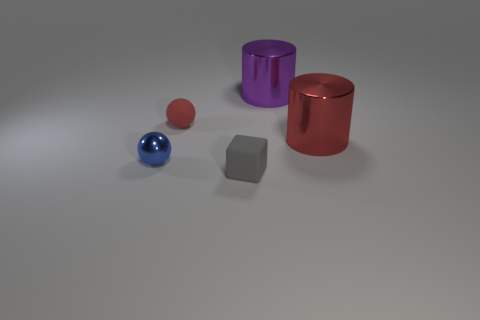Is the number of small gray cubes that are left of the small matte ball the same as the number of gray matte objects that are in front of the blue sphere?
Ensure brevity in your answer.  No. There is a object that is to the right of the purple shiny cylinder; what is its color?
Offer a terse response. Red. There is a small matte ball; does it have the same color as the metallic object on the left side of the big purple cylinder?
Make the answer very short. No. Are there fewer red rubber spheres than big yellow rubber cubes?
Ensure brevity in your answer.  No. Do the large shiny thing in front of the small red matte ball and the matte ball have the same color?
Your response must be concise. Yes. What number of gray rubber things have the same size as the purple metal cylinder?
Your answer should be very brief. 0. Is there a sphere of the same color as the small block?
Offer a very short reply. No. Does the big red object have the same material as the purple object?
Offer a terse response. Yes. How many small blue metal objects are the same shape as the tiny red object?
Provide a short and direct response. 1. There is a object that is the same material as the gray block; what is its shape?
Your response must be concise. Sphere. 